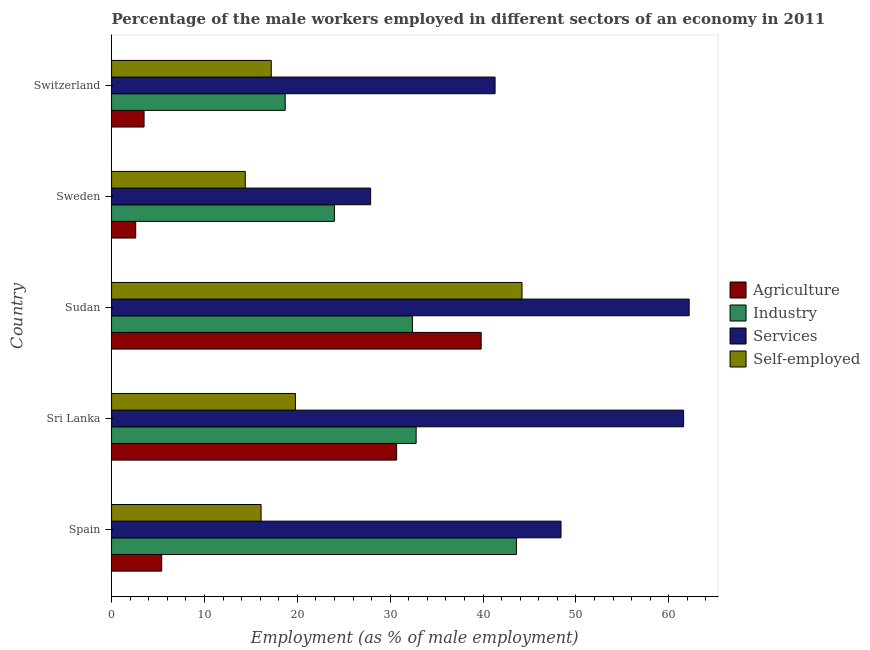How many different coloured bars are there?
Your answer should be compact. 4. Are the number of bars on each tick of the Y-axis equal?
Your response must be concise. Yes. How many bars are there on the 3rd tick from the top?
Provide a succinct answer. 4. What is the label of the 2nd group of bars from the top?
Your response must be concise. Sweden. What is the percentage of male workers in industry in Sudan?
Ensure brevity in your answer.  32.4. Across all countries, what is the maximum percentage of male workers in agriculture?
Make the answer very short. 39.8. Across all countries, what is the minimum percentage of male workers in services?
Provide a succinct answer. 27.9. In which country was the percentage of male workers in agriculture maximum?
Give a very brief answer. Sudan. In which country was the percentage of male workers in industry minimum?
Keep it short and to the point. Switzerland. What is the total percentage of self employed male workers in the graph?
Your answer should be compact. 111.7. What is the difference between the percentage of male workers in agriculture in Spain and that in Sudan?
Provide a short and direct response. -34.4. What is the difference between the percentage of male workers in agriculture in Sudan and the percentage of male workers in services in Spain?
Your response must be concise. -8.6. What is the difference between the percentage of male workers in agriculture and percentage of male workers in industry in Switzerland?
Your answer should be compact. -15.2. In how many countries, is the percentage of self employed male workers greater than 4 %?
Keep it short and to the point. 5. What is the ratio of the percentage of male workers in services in Sudan to that in Sweden?
Give a very brief answer. 2.23. What is the difference between the highest and the lowest percentage of male workers in industry?
Your answer should be very brief. 24.9. In how many countries, is the percentage of male workers in services greater than the average percentage of male workers in services taken over all countries?
Give a very brief answer. 3. What does the 2nd bar from the top in Switzerland represents?
Your answer should be very brief. Services. What does the 4th bar from the bottom in Switzerland represents?
Your answer should be very brief. Self-employed. How many bars are there?
Make the answer very short. 20. How many countries are there in the graph?
Keep it short and to the point. 5. Does the graph contain any zero values?
Offer a terse response. No. Does the graph contain grids?
Make the answer very short. No. Where does the legend appear in the graph?
Your answer should be very brief. Center right. How are the legend labels stacked?
Offer a very short reply. Vertical. What is the title of the graph?
Offer a very short reply. Percentage of the male workers employed in different sectors of an economy in 2011. Does "Tertiary education" appear as one of the legend labels in the graph?
Offer a terse response. No. What is the label or title of the X-axis?
Provide a succinct answer. Employment (as % of male employment). What is the Employment (as % of male employment) of Agriculture in Spain?
Give a very brief answer. 5.4. What is the Employment (as % of male employment) of Industry in Spain?
Your response must be concise. 43.6. What is the Employment (as % of male employment) of Services in Spain?
Give a very brief answer. 48.4. What is the Employment (as % of male employment) in Self-employed in Spain?
Give a very brief answer. 16.1. What is the Employment (as % of male employment) in Agriculture in Sri Lanka?
Your response must be concise. 30.7. What is the Employment (as % of male employment) of Industry in Sri Lanka?
Your response must be concise. 32.8. What is the Employment (as % of male employment) of Services in Sri Lanka?
Keep it short and to the point. 61.6. What is the Employment (as % of male employment) in Self-employed in Sri Lanka?
Offer a very short reply. 19.8. What is the Employment (as % of male employment) of Agriculture in Sudan?
Keep it short and to the point. 39.8. What is the Employment (as % of male employment) in Industry in Sudan?
Ensure brevity in your answer.  32.4. What is the Employment (as % of male employment) of Services in Sudan?
Provide a succinct answer. 62.2. What is the Employment (as % of male employment) of Self-employed in Sudan?
Make the answer very short. 44.2. What is the Employment (as % of male employment) in Agriculture in Sweden?
Offer a very short reply. 2.6. What is the Employment (as % of male employment) of Industry in Sweden?
Give a very brief answer. 24. What is the Employment (as % of male employment) of Services in Sweden?
Your answer should be very brief. 27.9. What is the Employment (as % of male employment) of Self-employed in Sweden?
Provide a short and direct response. 14.4. What is the Employment (as % of male employment) in Industry in Switzerland?
Ensure brevity in your answer.  18.7. What is the Employment (as % of male employment) of Services in Switzerland?
Offer a terse response. 41.3. What is the Employment (as % of male employment) of Self-employed in Switzerland?
Offer a very short reply. 17.2. Across all countries, what is the maximum Employment (as % of male employment) of Agriculture?
Provide a short and direct response. 39.8. Across all countries, what is the maximum Employment (as % of male employment) of Industry?
Your response must be concise. 43.6. Across all countries, what is the maximum Employment (as % of male employment) of Services?
Keep it short and to the point. 62.2. Across all countries, what is the maximum Employment (as % of male employment) in Self-employed?
Your response must be concise. 44.2. Across all countries, what is the minimum Employment (as % of male employment) in Agriculture?
Ensure brevity in your answer.  2.6. Across all countries, what is the minimum Employment (as % of male employment) in Industry?
Give a very brief answer. 18.7. Across all countries, what is the minimum Employment (as % of male employment) of Services?
Ensure brevity in your answer.  27.9. Across all countries, what is the minimum Employment (as % of male employment) of Self-employed?
Provide a succinct answer. 14.4. What is the total Employment (as % of male employment) in Industry in the graph?
Make the answer very short. 151.5. What is the total Employment (as % of male employment) in Services in the graph?
Offer a very short reply. 241.4. What is the total Employment (as % of male employment) of Self-employed in the graph?
Give a very brief answer. 111.7. What is the difference between the Employment (as % of male employment) in Agriculture in Spain and that in Sri Lanka?
Provide a succinct answer. -25.3. What is the difference between the Employment (as % of male employment) in Services in Spain and that in Sri Lanka?
Offer a terse response. -13.2. What is the difference between the Employment (as % of male employment) of Agriculture in Spain and that in Sudan?
Provide a short and direct response. -34.4. What is the difference between the Employment (as % of male employment) in Self-employed in Spain and that in Sudan?
Offer a terse response. -28.1. What is the difference between the Employment (as % of male employment) in Agriculture in Spain and that in Sweden?
Your answer should be very brief. 2.8. What is the difference between the Employment (as % of male employment) in Industry in Spain and that in Sweden?
Your response must be concise. 19.6. What is the difference between the Employment (as % of male employment) of Self-employed in Spain and that in Sweden?
Make the answer very short. 1.7. What is the difference between the Employment (as % of male employment) in Agriculture in Spain and that in Switzerland?
Your answer should be very brief. 1.9. What is the difference between the Employment (as % of male employment) of Industry in Spain and that in Switzerland?
Provide a succinct answer. 24.9. What is the difference between the Employment (as % of male employment) of Agriculture in Sri Lanka and that in Sudan?
Your response must be concise. -9.1. What is the difference between the Employment (as % of male employment) in Industry in Sri Lanka and that in Sudan?
Offer a terse response. 0.4. What is the difference between the Employment (as % of male employment) in Self-employed in Sri Lanka and that in Sudan?
Provide a succinct answer. -24.4. What is the difference between the Employment (as % of male employment) in Agriculture in Sri Lanka and that in Sweden?
Your answer should be very brief. 28.1. What is the difference between the Employment (as % of male employment) in Industry in Sri Lanka and that in Sweden?
Provide a succinct answer. 8.8. What is the difference between the Employment (as % of male employment) of Services in Sri Lanka and that in Sweden?
Offer a very short reply. 33.7. What is the difference between the Employment (as % of male employment) of Agriculture in Sri Lanka and that in Switzerland?
Give a very brief answer. 27.2. What is the difference between the Employment (as % of male employment) in Services in Sri Lanka and that in Switzerland?
Offer a very short reply. 20.3. What is the difference between the Employment (as % of male employment) of Agriculture in Sudan and that in Sweden?
Your answer should be very brief. 37.2. What is the difference between the Employment (as % of male employment) of Industry in Sudan and that in Sweden?
Your answer should be very brief. 8.4. What is the difference between the Employment (as % of male employment) of Services in Sudan and that in Sweden?
Your answer should be compact. 34.3. What is the difference between the Employment (as % of male employment) of Self-employed in Sudan and that in Sweden?
Your answer should be compact. 29.8. What is the difference between the Employment (as % of male employment) in Agriculture in Sudan and that in Switzerland?
Make the answer very short. 36.3. What is the difference between the Employment (as % of male employment) of Services in Sudan and that in Switzerland?
Make the answer very short. 20.9. What is the difference between the Employment (as % of male employment) of Self-employed in Sudan and that in Switzerland?
Provide a short and direct response. 27. What is the difference between the Employment (as % of male employment) in Industry in Sweden and that in Switzerland?
Your answer should be very brief. 5.3. What is the difference between the Employment (as % of male employment) in Self-employed in Sweden and that in Switzerland?
Your response must be concise. -2.8. What is the difference between the Employment (as % of male employment) in Agriculture in Spain and the Employment (as % of male employment) in Industry in Sri Lanka?
Ensure brevity in your answer.  -27.4. What is the difference between the Employment (as % of male employment) of Agriculture in Spain and the Employment (as % of male employment) of Services in Sri Lanka?
Give a very brief answer. -56.2. What is the difference between the Employment (as % of male employment) in Agriculture in Spain and the Employment (as % of male employment) in Self-employed in Sri Lanka?
Provide a succinct answer. -14.4. What is the difference between the Employment (as % of male employment) of Industry in Spain and the Employment (as % of male employment) of Self-employed in Sri Lanka?
Ensure brevity in your answer.  23.8. What is the difference between the Employment (as % of male employment) of Services in Spain and the Employment (as % of male employment) of Self-employed in Sri Lanka?
Your answer should be very brief. 28.6. What is the difference between the Employment (as % of male employment) in Agriculture in Spain and the Employment (as % of male employment) in Industry in Sudan?
Provide a succinct answer. -27. What is the difference between the Employment (as % of male employment) in Agriculture in Spain and the Employment (as % of male employment) in Services in Sudan?
Your answer should be very brief. -56.8. What is the difference between the Employment (as % of male employment) of Agriculture in Spain and the Employment (as % of male employment) of Self-employed in Sudan?
Keep it short and to the point. -38.8. What is the difference between the Employment (as % of male employment) of Industry in Spain and the Employment (as % of male employment) of Services in Sudan?
Your answer should be compact. -18.6. What is the difference between the Employment (as % of male employment) in Industry in Spain and the Employment (as % of male employment) in Self-employed in Sudan?
Offer a very short reply. -0.6. What is the difference between the Employment (as % of male employment) in Agriculture in Spain and the Employment (as % of male employment) in Industry in Sweden?
Provide a succinct answer. -18.6. What is the difference between the Employment (as % of male employment) of Agriculture in Spain and the Employment (as % of male employment) of Services in Sweden?
Offer a very short reply. -22.5. What is the difference between the Employment (as % of male employment) of Industry in Spain and the Employment (as % of male employment) of Services in Sweden?
Your answer should be compact. 15.7. What is the difference between the Employment (as % of male employment) in Industry in Spain and the Employment (as % of male employment) in Self-employed in Sweden?
Your answer should be compact. 29.2. What is the difference between the Employment (as % of male employment) in Services in Spain and the Employment (as % of male employment) in Self-employed in Sweden?
Provide a succinct answer. 34. What is the difference between the Employment (as % of male employment) in Agriculture in Spain and the Employment (as % of male employment) in Services in Switzerland?
Provide a succinct answer. -35.9. What is the difference between the Employment (as % of male employment) in Industry in Spain and the Employment (as % of male employment) in Services in Switzerland?
Make the answer very short. 2.3. What is the difference between the Employment (as % of male employment) of Industry in Spain and the Employment (as % of male employment) of Self-employed in Switzerland?
Your answer should be compact. 26.4. What is the difference between the Employment (as % of male employment) in Services in Spain and the Employment (as % of male employment) in Self-employed in Switzerland?
Provide a succinct answer. 31.2. What is the difference between the Employment (as % of male employment) of Agriculture in Sri Lanka and the Employment (as % of male employment) of Industry in Sudan?
Provide a succinct answer. -1.7. What is the difference between the Employment (as % of male employment) in Agriculture in Sri Lanka and the Employment (as % of male employment) in Services in Sudan?
Your response must be concise. -31.5. What is the difference between the Employment (as % of male employment) of Agriculture in Sri Lanka and the Employment (as % of male employment) of Self-employed in Sudan?
Your response must be concise. -13.5. What is the difference between the Employment (as % of male employment) of Industry in Sri Lanka and the Employment (as % of male employment) of Services in Sudan?
Your response must be concise. -29.4. What is the difference between the Employment (as % of male employment) of Industry in Sri Lanka and the Employment (as % of male employment) of Self-employed in Sudan?
Provide a succinct answer. -11.4. What is the difference between the Employment (as % of male employment) of Agriculture in Sri Lanka and the Employment (as % of male employment) of Self-employed in Sweden?
Make the answer very short. 16.3. What is the difference between the Employment (as % of male employment) in Industry in Sri Lanka and the Employment (as % of male employment) in Services in Sweden?
Provide a short and direct response. 4.9. What is the difference between the Employment (as % of male employment) of Industry in Sri Lanka and the Employment (as % of male employment) of Self-employed in Sweden?
Provide a short and direct response. 18.4. What is the difference between the Employment (as % of male employment) in Services in Sri Lanka and the Employment (as % of male employment) in Self-employed in Sweden?
Make the answer very short. 47.2. What is the difference between the Employment (as % of male employment) of Agriculture in Sri Lanka and the Employment (as % of male employment) of Self-employed in Switzerland?
Offer a very short reply. 13.5. What is the difference between the Employment (as % of male employment) in Industry in Sri Lanka and the Employment (as % of male employment) in Services in Switzerland?
Offer a very short reply. -8.5. What is the difference between the Employment (as % of male employment) of Services in Sri Lanka and the Employment (as % of male employment) of Self-employed in Switzerland?
Provide a succinct answer. 44.4. What is the difference between the Employment (as % of male employment) in Agriculture in Sudan and the Employment (as % of male employment) in Self-employed in Sweden?
Provide a succinct answer. 25.4. What is the difference between the Employment (as % of male employment) of Industry in Sudan and the Employment (as % of male employment) of Services in Sweden?
Keep it short and to the point. 4.5. What is the difference between the Employment (as % of male employment) in Industry in Sudan and the Employment (as % of male employment) in Self-employed in Sweden?
Your response must be concise. 18. What is the difference between the Employment (as % of male employment) in Services in Sudan and the Employment (as % of male employment) in Self-employed in Sweden?
Ensure brevity in your answer.  47.8. What is the difference between the Employment (as % of male employment) of Agriculture in Sudan and the Employment (as % of male employment) of Industry in Switzerland?
Your answer should be very brief. 21.1. What is the difference between the Employment (as % of male employment) of Agriculture in Sudan and the Employment (as % of male employment) of Services in Switzerland?
Your answer should be very brief. -1.5. What is the difference between the Employment (as % of male employment) of Agriculture in Sudan and the Employment (as % of male employment) of Self-employed in Switzerland?
Ensure brevity in your answer.  22.6. What is the difference between the Employment (as % of male employment) of Industry in Sudan and the Employment (as % of male employment) of Services in Switzerland?
Your response must be concise. -8.9. What is the difference between the Employment (as % of male employment) of Agriculture in Sweden and the Employment (as % of male employment) of Industry in Switzerland?
Ensure brevity in your answer.  -16.1. What is the difference between the Employment (as % of male employment) in Agriculture in Sweden and the Employment (as % of male employment) in Services in Switzerland?
Provide a short and direct response. -38.7. What is the difference between the Employment (as % of male employment) in Agriculture in Sweden and the Employment (as % of male employment) in Self-employed in Switzerland?
Provide a short and direct response. -14.6. What is the difference between the Employment (as % of male employment) of Industry in Sweden and the Employment (as % of male employment) of Services in Switzerland?
Make the answer very short. -17.3. What is the difference between the Employment (as % of male employment) in Services in Sweden and the Employment (as % of male employment) in Self-employed in Switzerland?
Provide a short and direct response. 10.7. What is the average Employment (as % of male employment) of Agriculture per country?
Offer a very short reply. 16.4. What is the average Employment (as % of male employment) of Industry per country?
Your answer should be very brief. 30.3. What is the average Employment (as % of male employment) of Services per country?
Offer a very short reply. 48.28. What is the average Employment (as % of male employment) of Self-employed per country?
Give a very brief answer. 22.34. What is the difference between the Employment (as % of male employment) of Agriculture and Employment (as % of male employment) of Industry in Spain?
Ensure brevity in your answer.  -38.2. What is the difference between the Employment (as % of male employment) in Agriculture and Employment (as % of male employment) in Services in Spain?
Offer a terse response. -43. What is the difference between the Employment (as % of male employment) in Agriculture and Employment (as % of male employment) in Self-employed in Spain?
Give a very brief answer. -10.7. What is the difference between the Employment (as % of male employment) in Industry and Employment (as % of male employment) in Services in Spain?
Ensure brevity in your answer.  -4.8. What is the difference between the Employment (as % of male employment) in Services and Employment (as % of male employment) in Self-employed in Spain?
Give a very brief answer. 32.3. What is the difference between the Employment (as % of male employment) of Agriculture and Employment (as % of male employment) of Industry in Sri Lanka?
Provide a short and direct response. -2.1. What is the difference between the Employment (as % of male employment) in Agriculture and Employment (as % of male employment) in Services in Sri Lanka?
Offer a very short reply. -30.9. What is the difference between the Employment (as % of male employment) in Agriculture and Employment (as % of male employment) in Self-employed in Sri Lanka?
Offer a very short reply. 10.9. What is the difference between the Employment (as % of male employment) in Industry and Employment (as % of male employment) in Services in Sri Lanka?
Provide a short and direct response. -28.8. What is the difference between the Employment (as % of male employment) of Services and Employment (as % of male employment) of Self-employed in Sri Lanka?
Offer a very short reply. 41.8. What is the difference between the Employment (as % of male employment) of Agriculture and Employment (as % of male employment) of Services in Sudan?
Ensure brevity in your answer.  -22.4. What is the difference between the Employment (as % of male employment) in Industry and Employment (as % of male employment) in Services in Sudan?
Provide a succinct answer. -29.8. What is the difference between the Employment (as % of male employment) of Industry and Employment (as % of male employment) of Self-employed in Sudan?
Your response must be concise. -11.8. What is the difference between the Employment (as % of male employment) of Services and Employment (as % of male employment) of Self-employed in Sudan?
Offer a very short reply. 18. What is the difference between the Employment (as % of male employment) in Agriculture and Employment (as % of male employment) in Industry in Sweden?
Keep it short and to the point. -21.4. What is the difference between the Employment (as % of male employment) in Agriculture and Employment (as % of male employment) in Services in Sweden?
Offer a terse response. -25.3. What is the difference between the Employment (as % of male employment) of Agriculture and Employment (as % of male employment) of Self-employed in Sweden?
Provide a short and direct response. -11.8. What is the difference between the Employment (as % of male employment) of Industry and Employment (as % of male employment) of Services in Sweden?
Give a very brief answer. -3.9. What is the difference between the Employment (as % of male employment) in Industry and Employment (as % of male employment) in Self-employed in Sweden?
Keep it short and to the point. 9.6. What is the difference between the Employment (as % of male employment) of Services and Employment (as % of male employment) of Self-employed in Sweden?
Offer a terse response. 13.5. What is the difference between the Employment (as % of male employment) in Agriculture and Employment (as % of male employment) in Industry in Switzerland?
Ensure brevity in your answer.  -15.2. What is the difference between the Employment (as % of male employment) in Agriculture and Employment (as % of male employment) in Services in Switzerland?
Offer a very short reply. -37.8. What is the difference between the Employment (as % of male employment) in Agriculture and Employment (as % of male employment) in Self-employed in Switzerland?
Give a very brief answer. -13.7. What is the difference between the Employment (as % of male employment) of Industry and Employment (as % of male employment) of Services in Switzerland?
Provide a succinct answer. -22.6. What is the difference between the Employment (as % of male employment) in Industry and Employment (as % of male employment) in Self-employed in Switzerland?
Offer a very short reply. 1.5. What is the difference between the Employment (as % of male employment) in Services and Employment (as % of male employment) in Self-employed in Switzerland?
Keep it short and to the point. 24.1. What is the ratio of the Employment (as % of male employment) of Agriculture in Spain to that in Sri Lanka?
Give a very brief answer. 0.18. What is the ratio of the Employment (as % of male employment) of Industry in Spain to that in Sri Lanka?
Your answer should be compact. 1.33. What is the ratio of the Employment (as % of male employment) of Services in Spain to that in Sri Lanka?
Your answer should be compact. 0.79. What is the ratio of the Employment (as % of male employment) in Self-employed in Spain to that in Sri Lanka?
Offer a very short reply. 0.81. What is the ratio of the Employment (as % of male employment) in Agriculture in Spain to that in Sudan?
Your answer should be compact. 0.14. What is the ratio of the Employment (as % of male employment) of Industry in Spain to that in Sudan?
Provide a succinct answer. 1.35. What is the ratio of the Employment (as % of male employment) in Services in Spain to that in Sudan?
Your answer should be compact. 0.78. What is the ratio of the Employment (as % of male employment) of Self-employed in Spain to that in Sudan?
Your response must be concise. 0.36. What is the ratio of the Employment (as % of male employment) in Agriculture in Spain to that in Sweden?
Offer a terse response. 2.08. What is the ratio of the Employment (as % of male employment) in Industry in Spain to that in Sweden?
Provide a succinct answer. 1.82. What is the ratio of the Employment (as % of male employment) of Services in Spain to that in Sweden?
Provide a short and direct response. 1.73. What is the ratio of the Employment (as % of male employment) in Self-employed in Spain to that in Sweden?
Keep it short and to the point. 1.12. What is the ratio of the Employment (as % of male employment) in Agriculture in Spain to that in Switzerland?
Provide a succinct answer. 1.54. What is the ratio of the Employment (as % of male employment) of Industry in Spain to that in Switzerland?
Provide a succinct answer. 2.33. What is the ratio of the Employment (as % of male employment) in Services in Spain to that in Switzerland?
Give a very brief answer. 1.17. What is the ratio of the Employment (as % of male employment) in Self-employed in Spain to that in Switzerland?
Give a very brief answer. 0.94. What is the ratio of the Employment (as % of male employment) in Agriculture in Sri Lanka to that in Sudan?
Ensure brevity in your answer.  0.77. What is the ratio of the Employment (as % of male employment) of Industry in Sri Lanka to that in Sudan?
Provide a short and direct response. 1.01. What is the ratio of the Employment (as % of male employment) in Services in Sri Lanka to that in Sudan?
Give a very brief answer. 0.99. What is the ratio of the Employment (as % of male employment) in Self-employed in Sri Lanka to that in Sudan?
Offer a very short reply. 0.45. What is the ratio of the Employment (as % of male employment) of Agriculture in Sri Lanka to that in Sweden?
Provide a short and direct response. 11.81. What is the ratio of the Employment (as % of male employment) in Industry in Sri Lanka to that in Sweden?
Make the answer very short. 1.37. What is the ratio of the Employment (as % of male employment) of Services in Sri Lanka to that in Sweden?
Give a very brief answer. 2.21. What is the ratio of the Employment (as % of male employment) of Self-employed in Sri Lanka to that in Sweden?
Provide a succinct answer. 1.38. What is the ratio of the Employment (as % of male employment) in Agriculture in Sri Lanka to that in Switzerland?
Provide a succinct answer. 8.77. What is the ratio of the Employment (as % of male employment) of Industry in Sri Lanka to that in Switzerland?
Your answer should be very brief. 1.75. What is the ratio of the Employment (as % of male employment) in Services in Sri Lanka to that in Switzerland?
Ensure brevity in your answer.  1.49. What is the ratio of the Employment (as % of male employment) of Self-employed in Sri Lanka to that in Switzerland?
Provide a succinct answer. 1.15. What is the ratio of the Employment (as % of male employment) in Agriculture in Sudan to that in Sweden?
Ensure brevity in your answer.  15.31. What is the ratio of the Employment (as % of male employment) in Industry in Sudan to that in Sweden?
Keep it short and to the point. 1.35. What is the ratio of the Employment (as % of male employment) in Services in Sudan to that in Sweden?
Offer a very short reply. 2.23. What is the ratio of the Employment (as % of male employment) of Self-employed in Sudan to that in Sweden?
Provide a succinct answer. 3.07. What is the ratio of the Employment (as % of male employment) of Agriculture in Sudan to that in Switzerland?
Provide a short and direct response. 11.37. What is the ratio of the Employment (as % of male employment) in Industry in Sudan to that in Switzerland?
Ensure brevity in your answer.  1.73. What is the ratio of the Employment (as % of male employment) of Services in Sudan to that in Switzerland?
Provide a succinct answer. 1.51. What is the ratio of the Employment (as % of male employment) in Self-employed in Sudan to that in Switzerland?
Provide a short and direct response. 2.57. What is the ratio of the Employment (as % of male employment) of Agriculture in Sweden to that in Switzerland?
Offer a very short reply. 0.74. What is the ratio of the Employment (as % of male employment) of Industry in Sweden to that in Switzerland?
Make the answer very short. 1.28. What is the ratio of the Employment (as % of male employment) of Services in Sweden to that in Switzerland?
Provide a short and direct response. 0.68. What is the ratio of the Employment (as % of male employment) of Self-employed in Sweden to that in Switzerland?
Your answer should be compact. 0.84. What is the difference between the highest and the second highest Employment (as % of male employment) in Services?
Provide a short and direct response. 0.6. What is the difference between the highest and the second highest Employment (as % of male employment) in Self-employed?
Offer a terse response. 24.4. What is the difference between the highest and the lowest Employment (as % of male employment) of Agriculture?
Your response must be concise. 37.2. What is the difference between the highest and the lowest Employment (as % of male employment) of Industry?
Provide a short and direct response. 24.9. What is the difference between the highest and the lowest Employment (as % of male employment) of Services?
Make the answer very short. 34.3. What is the difference between the highest and the lowest Employment (as % of male employment) of Self-employed?
Your response must be concise. 29.8. 